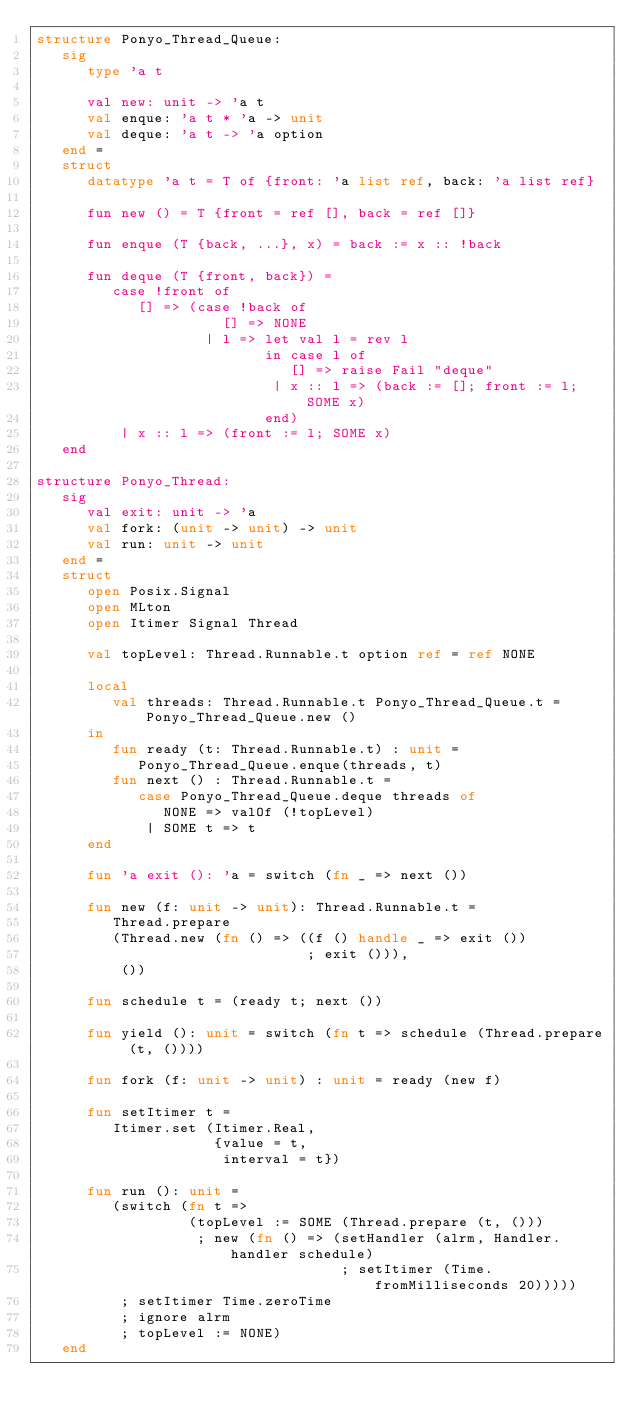<code> <loc_0><loc_0><loc_500><loc_500><_SML_>structure Ponyo_Thread_Queue:
   sig
      type 'a t

      val new: unit -> 'a t
      val enque: 'a t * 'a -> unit
      val deque: 'a t -> 'a option
   end =
   struct
      datatype 'a t = T of {front: 'a list ref, back: 'a list ref}

      fun new () = T {front = ref [], back = ref []}

      fun enque (T {back, ...}, x) = back := x :: !back

      fun deque (T {front, back}) =
         case !front of
            [] => (case !back of
                      [] => NONE
                    | l => let val l = rev l
                           in case l of
                              [] => raise Fail "deque"
                            | x :: l => (back := []; front := l; SOME x)
                           end)
          | x :: l => (front := l; SOME x)
   end

structure Ponyo_Thread:
   sig
      val exit: unit -> 'a
      val fork: (unit -> unit) -> unit
      val run: unit -> unit
   end =
   struct
      open Posix.Signal
      open MLton
      open Itimer Signal Thread

      val topLevel: Thread.Runnable.t option ref = ref NONE

      local
         val threads: Thread.Runnable.t Ponyo_Thread_Queue.t = Ponyo_Thread_Queue.new ()
      in
         fun ready (t: Thread.Runnable.t) : unit =
            Ponyo_Thread_Queue.enque(threads, t)
         fun next () : Thread.Runnable.t =
            case Ponyo_Thread_Queue.deque threads of
               NONE => valOf (!topLevel)
             | SOME t => t
      end

      fun 'a exit (): 'a = switch (fn _ => next ())

      fun new (f: unit -> unit): Thread.Runnable.t =
         Thread.prepare
         (Thread.new (fn () => ((f () handle _ => exit ())
                                ; exit ())),
          ())

      fun schedule t = (ready t; next ())

      fun yield (): unit = switch (fn t => schedule (Thread.prepare (t, ())))

      fun fork (f: unit -> unit) : unit = ready (new f)

      fun setItimer t =
         Itimer.set (Itimer.Real,
                     {value = t,
                      interval = t})

      fun run (): unit =
         (switch (fn t =>
                  (topLevel := SOME (Thread.prepare (t, ()))
                   ; new (fn () => (setHandler (alrm, Handler.handler schedule)
                                    ; setItimer (Time.fromMilliseconds 20)))))
          ; setItimer Time.zeroTime
          ; ignore alrm
          ; topLevel := NONE)
   end</code> 